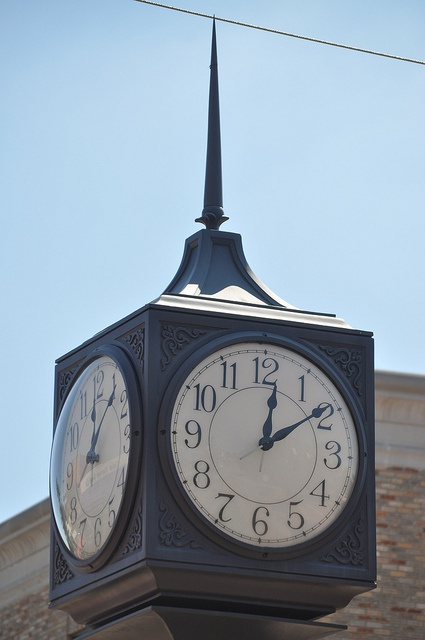Describe the objects in this image and their specific colors. I can see clock in lightblue, darkgray, gray, and black tones and clock in lightblue, darkgray, gray, and black tones in this image. 